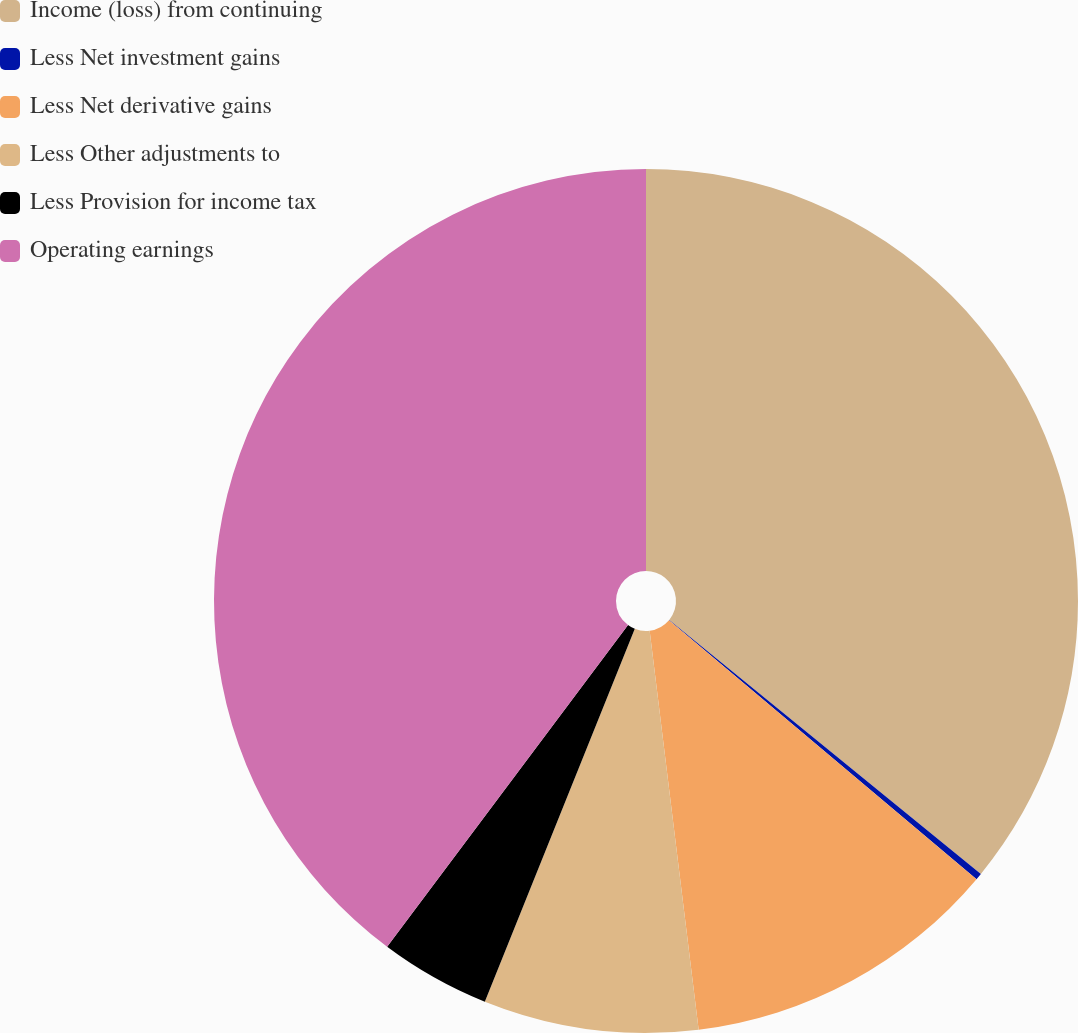Convert chart. <chart><loc_0><loc_0><loc_500><loc_500><pie_chart><fcel>Income (loss) from continuing<fcel>Less Net investment gains<fcel>Less Net derivative gains<fcel>Less Other adjustments to<fcel>Less Provision for income tax<fcel>Operating earnings<nl><fcel>35.88%<fcel>0.25%<fcel>11.92%<fcel>8.03%<fcel>4.14%<fcel>39.77%<nl></chart> 